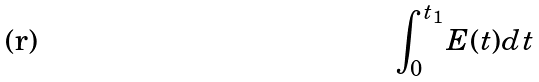Convert formula to latex. <formula><loc_0><loc_0><loc_500><loc_500>\int _ { 0 } ^ { t _ { 1 } } E ( t ) d t</formula> 